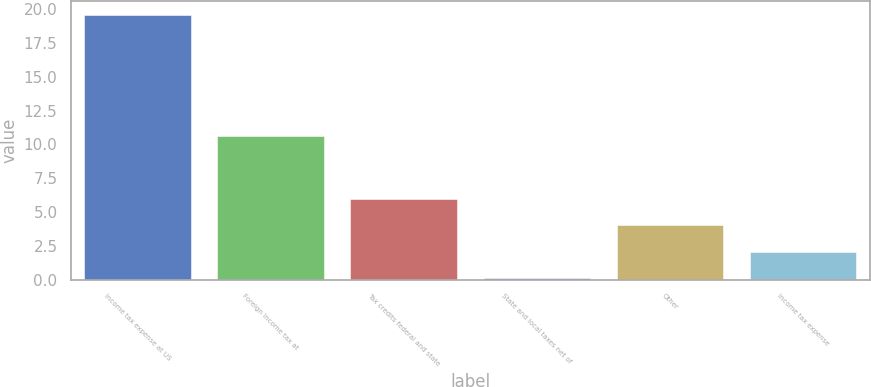<chart> <loc_0><loc_0><loc_500><loc_500><bar_chart><fcel>Income tax expense at US<fcel>Foreign income tax at<fcel>Tax credits federal and state<fcel>State and local taxes net of<fcel>Other<fcel>Income tax expense<nl><fcel>19.6<fcel>10.6<fcel>5.95<fcel>0.1<fcel>4<fcel>2.05<nl></chart> 